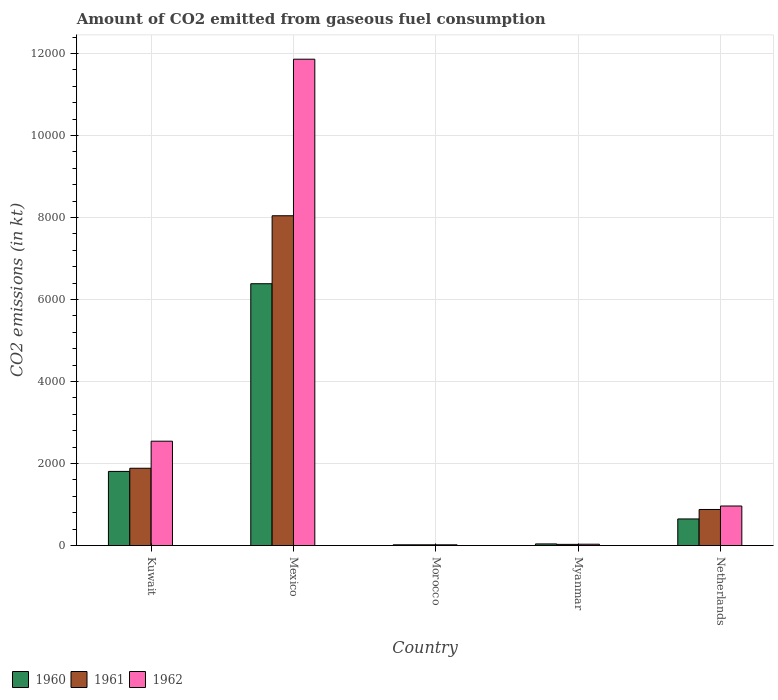How many different coloured bars are there?
Offer a very short reply. 3. How many groups of bars are there?
Your response must be concise. 5. Are the number of bars on each tick of the X-axis equal?
Offer a terse response. Yes. What is the label of the 4th group of bars from the left?
Offer a terse response. Myanmar. In how many cases, is the number of bars for a given country not equal to the number of legend labels?
Provide a succinct answer. 0. What is the amount of CO2 emitted in 1961 in Morocco?
Ensure brevity in your answer.  18.34. Across all countries, what is the maximum amount of CO2 emitted in 1961?
Your answer should be very brief. 8041.73. Across all countries, what is the minimum amount of CO2 emitted in 1961?
Ensure brevity in your answer.  18.34. In which country was the amount of CO2 emitted in 1961 minimum?
Offer a very short reply. Morocco. What is the total amount of CO2 emitted in 1960 in the graph?
Offer a very short reply. 8899.81. What is the difference between the amount of CO2 emitted in 1960 in Mexico and that in Morocco?
Provide a short and direct response. 6365.91. What is the difference between the amount of CO2 emitted in 1961 in Myanmar and the amount of CO2 emitted in 1962 in Morocco?
Provide a succinct answer. 11. What is the average amount of CO2 emitted in 1961 per country?
Make the answer very short. 2170.86. What is the difference between the amount of CO2 emitted of/in 1962 and amount of CO2 emitted of/in 1960 in Morocco?
Your answer should be very brief. 0. What is the ratio of the amount of CO2 emitted in 1960 in Mexico to that in Myanmar?
Your response must be concise. 158.27. Is the amount of CO2 emitted in 1960 in Mexico less than that in Netherlands?
Provide a short and direct response. No. What is the difference between the highest and the second highest amount of CO2 emitted in 1960?
Provide a short and direct response. 5735.19. What is the difference between the highest and the lowest amount of CO2 emitted in 1961?
Make the answer very short. 8023.4. Are all the bars in the graph horizontal?
Provide a succinct answer. No. Does the graph contain any zero values?
Your answer should be very brief. No. Where does the legend appear in the graph?
Ensure brevity in your answer.  Bottom left. How many legend labels are there?
Your answer should be very brief. 3. What is the title of the graph?
Keep it short and to the point. Amount of CO2 emitted from gaseous fuel consumption. Does "1975" appear as one of the legend labels in the graph?
Keep it short and to the point. No. What is the label or title of the X-axis?
Offer a terse response. Country. What is the label or title of the Y-axis?
Your response must be concise. CO2 emissions (in kt). What is the CO2 emissions (in kt) in 1960 in Kuwait?
Keep it short and to the point. 1807.83. What is the CO2 emissions (in kt) in 1961 in Kuwait?
Offer a terse response. 1884.84. What is the CO2 emissions (in kt) in 1962 in Kuwait?
Offer a terse response. 2544.9. What is the CO2 emissions (in kt) in 1960 in Mexico?
Your response must be concise. 6384.25. What is the CO2 emissions (in kt) in 1961 in Mexico?
Provide a short and direct response. 8041.73. What is the CO2 emissions (in kt) of 1962 in Mexico?
Ensure brevity in your answer.  1.19e+04. What is the CO2 emissions (in kt) in 1960 in Morocco?
Your answer should be very brief. 18.34. What is the CO2 emissions (in kt) in 1961 in Morocco?
Make the answer very short. 18.34. What is the CO2 emissions (in kt) of 1962 in Morocco?
Your answer should be very brief. 18.34. What is the CO2 emissions (in kt) of 1960 in Myanmar?
Your answer should be very brief. 40.34. What is the CO2 emissions (in kt) in 1961 in Myanmar?
Provide a succinct answer. 29.34. What is the CO2 emissions (in kt) of 1962 in Myanmar?
Give a very brief answer. 33. What is the CO2 emissions (in kt) in 1960 in Netherlands?
Provide a succinct answer. 649.06. What is the CO2 emissions (in kt) of 1961 in Netherlands?
Give a very brief answer. 880.08. What is the CO2 emissions (in kt) of 1962 in Netherlands?
Ensure brevity in your answer.  964.42. Across all countries, what is the maximum CO2 emissions (in kt) in 1960?
Your answer should be compact. 6384.25. Across all countries, what is the maximum CO2 emissions (in kt) of 1961?
Your response must be concise. 8041.73. Across all countries, what is the maximum CO2 emissions (in kt) in 1962?
Your answer should be very brief. 1.19e+04. Across all countries, what is the minimum CO2 emissions (in kt) in 1960?
Make the answer very short. 18.34. Across all countries, what is the minimum CO2 emissions (in kt) of 1961?
Your answer should be compact. 18.34. Across all countries, what is the minimum CO2 emissions (in kt) of 1962?
Your answer should be very brief. 18.34. What is the total CO2 emissions (in kt) in 1960 in the graph?
Provide a short and direct response. 8899.81. What is the total CO2 emissions (in kt) of 1961 in the graph?
Your response must be concise. 1.09e+04. What is the total CO2 emissions (in kt) of 1962 in the graph?
Provide a short and direct response. 1.54e+04. What is the difference between the CO2 emissions (in kt) of 1960 in Kuwait and that in Mexico?
Your answer should be very brief. -4576.42. What is the difference between the CO2 emissions (in kt) of 1961 in Kuwait and that in Mexico?
Keep it short and to the point. -6156.89. What is the difference between the CO2 emissions (in kt) in 1962 in Kuwait and that in Mexico?
Provide a succinct answer. -9314.18. What is the difference between the CO2 emissions (in kt) of 1960 in Kuwait and that in Morocco?
Offer a very short reply. 1789.5. What is the difference between the CO2 emissions (in kt) of 1961 in Kuwait and that in Morocco?
Offer a terse response. 1866.5. What is the difference between the CO2 emissions (in kt) of 1962 in Kuwait and that in Morocco?
Provide a short and direct response. 2526.56. What is the difference between the CO2 emissions (in kt) of 1960 in Kuwait and that in Myanmar?
Give a very brief answer. 1767.49. What is the difference between the CO2 emissions (in kt) of 1961 in Kuwait and that in Myanmar?
Keep it short and to the point. 1855.5. What is the difference between the CO2 emissions (in kt) in 1962 in Kuwait and that in Myanmar?
Keep it short and to the point. 2511.89. What is the difference between the CO2 emissions (in kt) in 1960 in Kuwait and that in Netherlands?
Keep it short and to the point. 1158.77. What is the difference between the CO2 emissions (in kt) of 1961 in Kuwait and that in Netherlands?
Make the answer very short. 1004.76. What is the difference between the CO2 emissions (in kt) in 1962 in Kuwait and that in Netherlands?
Ensure brevity in your answer.  1580.48. What is the difference between the CO2 emissions (in kt) of 1960 in Mexico and that in Morocco?
Make the answer very short. 6365.91. What is the difference between the CO2 emissions (in kt) in 1961 in Mexico and that in Morocco?
Offer a very short reply. 8023.4. What is the difference between the CO2 emissions (in kt) of 1962 in Mexico and that in Morocco?
Give a very brief answer. 1.18e+04. What is the difference between the CO2 emissions (in kt) in 1960 in Mexico and that in Myanmar?
Give a very brief answer. 6343.91. What is the difference between the CO2 emissions (in kt) of 1961 in Mexico and that in Myanmar?
Ensure brevity in your answer.  8012.4. What is the difference between the CO2 emissions (in kt) in 1962 in Mexico and that in Myanmar?
Your answer should be compact. 1.18e+04. What is the difference between the CO2 emissions (in kt) of 1960 in Mexico and that in Netherlands?
Provide a succinct answer. 5735.19. What is the difference between the CO2 emissions (in kt) of 1961 in Mexico and that in Netherlands?
Provide a short and direct response. 7161.65. What is the difference between the CO2 emissions (in kt) of 1962 in Mexico and that in Netherlands?
Your answer should be compact. 1.09e+04. What is the difference between the CO2 emissions (in kt) of 1960 in Morocco and that in Myanmar?
Your answer should be very brief. -22. What is the difference between the CO2 emissions (in kt) in 1961 in Morocco and that in Myanmar?
Ensure brevity in your answer.  -11. What is the difference between the CO2 emissions (in kt) of 1962 in Morocco and that in Myanmar?
Keep it short and to the point. -14.67. What is the difference between the CO2 emissions (in kt) in 1960 in Morocco and that in Netherlands?
Offer a terse response. -630.72. What is the difference between the CO2 emissions (in kt) of 1961 in Morocco and that in Netherlands?
Provide a succinct answer. -861.75. What is the difference between the CO2 emissions (in kt) in 1962 in Morocco and that in Netherlands?
Provide a succinct answer. -946.09. What is the difference between the CO2 emissions (in kt) in 1960 in Myanmar and that in Netherlands?
Your answer should be compact. -608.72. What is the difference between the CO2 emissions (in kt) of 1961 in Myanmar and that in Netherlands?
Your answer should be compact. -850.74. What is the difference between the CO2 emissions (in kt) in 1962 in Myanmar and that in Netherlands?
Your answer should be very brief. -931.42. What is the difference between the CO2 emissions (in kt) of 1960 in Kuwait and the CO2 emissions (in kt) of 1961 in Mexico?
Provide a short and direct response. -6233.9. What is the difference between the CO2 emissions (in kt) in 1960 in Kuwait and the CO2 emissions (in kt) in 1962 in Mexico?
Keep it short and to the point. -1.01e+04. What is the difference between the CO2 emissions (in kt) of 1961 in Kuwait and the CO2 emissions (in kt) of 1962 in Mexico?
Ensure brevity in your answer.  -9974.24. What is the difference between the CO2 emissions (in kt) of 1960 in Kuwait and the CO2 emissions (in kt) of 1961 in Morocco?
Your answer should be very brief. 1789.5. What is the difference between the CO2 emissions (in kt) of 1960 in Kuwait and the CO2 emissions (in kt) of 1962 in Morocco?
Your response must be concise. 1789.5. What is the difference between the CO2 emissions (in kt) of 1961 in Kuwait and the CO2 emissions (in kt) of 1962 in Morocco?
Give a very brief answer. 1866.5. What is the difference between the CO2 emissions (in kt) of 1960 in Kuwait and the CO2 emissions (in kt) of 1961 in Myanmar?
Keep it short and to the point. 1778.49. What is the difference between the CO2 emissions (in kt) of 1960 in Kuwait and the CO2 emissions (in kt) of 1962 in Myanmar?
Offer a terse response. 1774.83. What is the difference between the CO2 emissions (in kt) of 1961 in Kuwait and the CO2 emissions (in kt) of 1962 in Myanmar?
Offer a very short reply. 1851.84. What is the difference between the CO2 emissions (in kt) in 1960 in Kuwait and the CO2 emissions (in kt) in 1961 in Netherlands?
Provide a short and direct response. 927.75. What is the difference between the CO2 emissions (in kt) in 1960 in Kuwait and the CO2 emissions (in kt) in 1962 in Netherlands?
Ensure brevity in your answer.  843.41. What is the difference between the CO2 emissions (in kt) of 1961 in Kuwait and the CO2 emissions (in kt) of 1962 in Netherlands?
Your answer should be very brief. 920.42. What is the difference between the CO2 emissions (in kt) of 1960 in Mexico and the CO2 emissions (in kt) of 1961 in Morocco?
Ensure brevity in your answer.  6365.91. What is the difference between the CO2 emissions (in kt) of 1960 in Mexico and the CO2 emissions (in kt) of 1962 in Morocco?
Make the answer very short. 6365.91. What is the difference between the CO2 emissions (in kt) in 1961 in Mexico and the CO2 emissions (in kt) in 1962 in Morocco?
Ensure brevity in your answer.  8023.4. What is the difference between the CO2 emissions (in kt) of 1960 in Mexico and the CO2 emissions (in kt) of 1961 in Myanmar?
Your answer should be very brief. 6354.91. What is the difference between the CO2 emissions (in kt) in 1960 in Mexico and the CO2 emissions (in kt) in 1962 in Myanmar?
Keep it short and to the point. 6351.24. What is the difference between the CO2 emissions (in kt) of 1961 in Mexico and the CO2 emissions (in kt) of 1962 in Myanmar?
Make the answer very short. 8008.73. What is the difference between the CO2 emissions (in kt) of 1960 in Mexico and the CO2 emissions (in kt) of 1961 in Netherlands?
Offer a very short reply. 5504.17. What is the difference between the CO2 emissions (in kt) of 1960 in Mexico and the CO2 emissions (in kt) of 1962 in Netherlands?
Your response must be concise. 5419.83. What is the difference between the CO2 emissions (in kt) in 1961 in Mexico and the CO2 emissions (in kt) in 1962 in Netherlands?
Your answer should be compact. 7077.31. What is the difference between the CO2 emissions (in kt) in 1960 in Morocco and the CO2 emissions (in kt) in 1961 in Myanmar?
Your answer should be very brief. -11. What is the difference between the CO2 emissions (in kt) in 1960 in Morocco and the CO2 emissions (in kt) in 1962 in Myanmar?
Give a very brief answer. -14.67. What is the difference between the CO2 emissions (in kt) in 1961 in Morocco and the CO2 emissions (in kt) in 1962 in Myanmar?
Offer a very short reply. -14.67. What is the difference between the CO2 emissions (in kt) in 1960 in Morocco and the CO2 emissions (in kt) in 1961 in Netherlands?
Make the answer very short. -861.75. What is the difference between the CO2 emissions (in kt) of 1960 in Morocco and the CO2 emissions (in kt) of 1962 in Netherlands?
Your answer should be compact. -946.09. What is the difference between the CO2 emissions (in kt) of 1961 in Morocco and the CO2 emissions (in kt) of 1962 in Netherlands?
Your answer should be very brief. -946.09. What is the difference between the CO2 emissions (in kt) of 1960 in Myanmar and the CO2 emissions (in kt) of 1961 in Netherlands?
Your answer should be very brief. -839.74. What is the difference between the CO2 emissions (in kt) of 1960 in Myanmar and the CO2 emissions (in kt) of 1962 in Netherlands?
Provide a short and direct response. -924.08. What is the difference between the CO2 emissions (in kt) in 1961 in Myanmar and the CO2 emissions (in kt) in 1962 in Netherlands?
Offer a very short reply. -935.09. What is the average CO2 emissions (in kt) in 1960 per country?
Your response must be concise. 1779.96. What is the average CO2 emissions (in kt) in 1961 per country?
Ensure brevity in your answer.  2170.86. What is the average CO2 emissions (in kt) in 1962 per country?
Offer a terse response. 3083.95. What is the difference between the CO2 emissions (in kt) in 1960 and CO2 emissions (in kt) in 1961 in Kuwait?
Keep it short and to the point. -77.01. What is the difference between the CO2 emissions (in kt) of 1960 and CO2 emissions (in kt) of 1962 in Kuwait?
Provide a short and direct response. -737.07. What is the difference between the CO2 emissions (in kt) in 1961 and CO2 emissions (in kt) in 1962 in Kuwait?
Your response must be concise. -660.06. What is the difference between the CO2 emissions (in kt) in 1960 and CO2 emissions (in kt) in 1961 in Mexico?
Your answer should be very brief. -1657.48. What is the difference between the CO2 emissions (in kt) of 1960 and CO2 emissions (in kt) of 1962 in Mexico?
Offer a very short reply. -5474.83. What is the difference between the CO2 emissions (in kt) in 1961 and CO2 emissions (in kt) in 1962 in Mexico?
Ensure brevity in your answer.  -3817.35. What is the difference between the CO2 emissions (in kt) in 1960 and CO2 emissions (in kt) in 1961 in Myanmar?
Your answer should be very brief. 11. What is the difference between the CO2 emissions (in kt) of 1960 and CO2 emissions (in kt) of 1962 in Myanmar?
Provide a succinct answer. 7.33. What is the difference between the CO2 emissions (in kt) in 1961 and CO2 emissions (in kt) in 1962 in Myanmar?
Offer a very short reply. -3.67. What is the difference between the CO2 emissions (in kt) of 1960 and CO2 emissions (in kt) of 1961 in Netherlands?
Offer a very short reply. -231.02. What is the difference between the CO2 emissions (in kt) of 1960 and CO2 emissions (in kt) of 1962 in Netherlands?
Your answer should be very brief. -315.36. What is the difference between the CO2 emissions (in kt) of 1961 and CO2 emissions (in kt) of 1962 in Netherlands?
Provide a succinct answer. -84.34. What is the ratio of the CO2 emissions (in kt) in 1960 in Kuwait to that in Mexico?
Offer a terse response. 0.28. What is the ratio of the CO2 emissions (in kt) of 1961 in Kuwait to that in Mexico?
Ensure brevity in your answer.  0.23. What is the ratio of the CO2 emissions (in kt) of 1962 in Kuwait to that in Mexico?
Offer a terse response. 0.21. What is the ratio of the CO2 emissions (in kt) in 1960 in Kuwait to that in Morocco?
Offer a terse response. 98.6. What is the ratio of the CO2 emissions (in kt) in 1961 in Kuwait to that in Morocco?
Make the answer very short. 102.8. What is the ratio of the CO2 emissions (in kt) in 1962 in Kuwait to that in Morocco?
Ensure brevity in your answer.  138.8. What is the ratio of the CO2 emissions (in kt) in 1960 in Kuwait to that in Myanmar?
Provide a succinct answer. 44.82. What is the ratio of the CO2 emissions (in kt) in 1961 in Kuwait to that in Myanmar?
Make the answer very short. 64.25. What is the ratio of the CO2 emissions (in kt) in 1962 in Kuwait to that in Myanmar?
Offer a terse response. 77.11. What is the ratio of the CO2 emissions (in kt) in 1960 in Kuwait to that in Netherlands?
Provide a succinct answer. 2.79. What is the ratio of the CO2 emissions (in kt) in 1961 in Kuwait to that in Netherlands?
Your answer should be very brief. 2.14. What is the ratio of the CO2 emissions (in kt) in 1962 in Kuwait to that in Netherlands?
Ensure brevity in your answer.  2.64. What is the ratio of the CO2 emissions (in kt) in 1960 in Mexico to that in Morocco?
Your response must be concise. 348.2. What is the ratio of the CO2 emissions (in kt) of 1961 in Mexico to that in Morocco?
Your answer should be compact. 438.6. What is the ratio of the CO2 emissions (in kt) in 1962 in Mexico to that in Morocco?
Make the answer very short. 646.8. What is the ratio of the CO2 emissions (in kt) in 1960 in Mexico to that in Myanmar?
Keep it short and to the point. 158.27. What is the ratio of the CO2 emissions (in kt) of 1961 in Mexico to that in Myanmar?
Give a very brief answer. 274.12. What is the ratio of the CO2 emissions (in kt) of 1962 in Mexico to that in Myanmar?
Ensure brevity in your answer.  359.33. What is the ratio of the CO2 emissions (in kt) in 1960 in Mexico to that in Netherlands?
Keep it short and to the point. 9.84. What is the ratio of the CO2 emissions (in kt) of 1961 in Mexico to that in Netherlands?
Offer a very short reply. 9.14. What is the ratio of the CO2 emissions (in kt) of 1962 in Mexico to that in Netherlands?
Provide a short and direct response. 12.3. What is the ratio of the CO2 emissions (in kt) of 1960 in Morocco to that in Myanmar?
Your response must be concise. 0.45. What is the ratio of the CO2 emissions (in kt) in 1961 in Morocco to that in Myanmar?
Offer a terse response. 0.62. What is the ratio of the CO2 emissions (in kt) of 1962 in Morocco to that in Myanmar?
Your answer should be very brief. 0.56. What is the ratio of the CO2 emissions (in kt) of 1960 in Morocco to that in Netherlands?
Make the answer very short. 0.03. What is the ratio of the CO2 emissions (in kt) of 1961 in Morocco to that in Netherlands?
Offer a terse response. 0.02. What is the ratio of the CO2 emissions (in kt) of 1962 in Morocco to that in Netherlands?
Offer a terse response. 0.02. What is the ratio of the CO2 emissions (in kt) in 1960 in Myanmar to that in Netherlands?
Your answer should be very brief. 0.06. What is the ratio of the CO2 emissions (in kt) in 1962 in Myanmar to that in Netherlands?
Your answer should be very brief. 0.03. What is the difference between the highest and the second highest CO2 emissions (in kt) in 1960?
Provide a short and direct response. 4576.42. What is the difference between the highest and the second highest CO2 emissions (in kt) of 1961?
Offer a terse response. 6156.89. What is the difference between the highest and the second highest CO2 emissions (in kt) in 1962?
Provide a short and direct response. 9314.18. What is the difference between the highest and the lowest CO2 emissions (in kt) in 1960?
Your answer should be compact. 6365.91. What is the difference between the highest and the lowest CO2 emissions (in kt) of 1961?
Ensure brevity in your answer.  8023.4. What is the difference between the highest and the lowest CO2 emissions (in kt) in 1962?
Your response must be concise. 1.18e+04. 